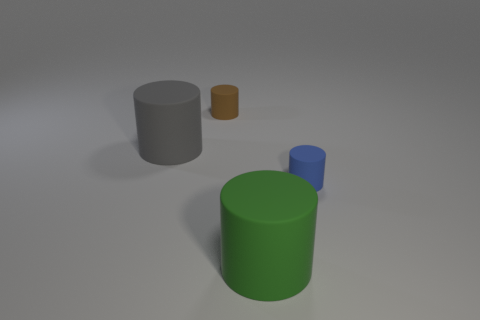How many blocks are tiny cyan metallic objects or small blue rubber things?
Provide a short and direct response. 0. What color is the other large cylinder that is made of the same material as the large green cylinder?
Provide a succinct answer. Gray. What number of things are either small brown metallic things or blue matte cylinders?
Make the answer very short. 1. Is there a small brown object of the same shape as the green thing?
Provide a short and direct response. Yes. What number of cylinders are to the right of the brown cylinder?
Give a very brief answer. 2. Is there a brown rubber cylinder of the same size as the blue thing?
Offer a very short reply. Yes. There is a big cylinder to the right of the brown rubber cylinder; what is its color?
Ensure brevity in your answer.  Green. Are there any large green rubber objects that are right of the large object that is on the left side of the tiny brown cylinder?
Your response must be concise. Yes. Do the thing on the right side of the green matte object and the cylinder to the left of the small brown rubber thing have the same size?
Provide a succinct answer. No. How big is the gray object that is to the left of the large cylinder that is on the right side of the gray matte thing?
Offer a very short reply. Large. 